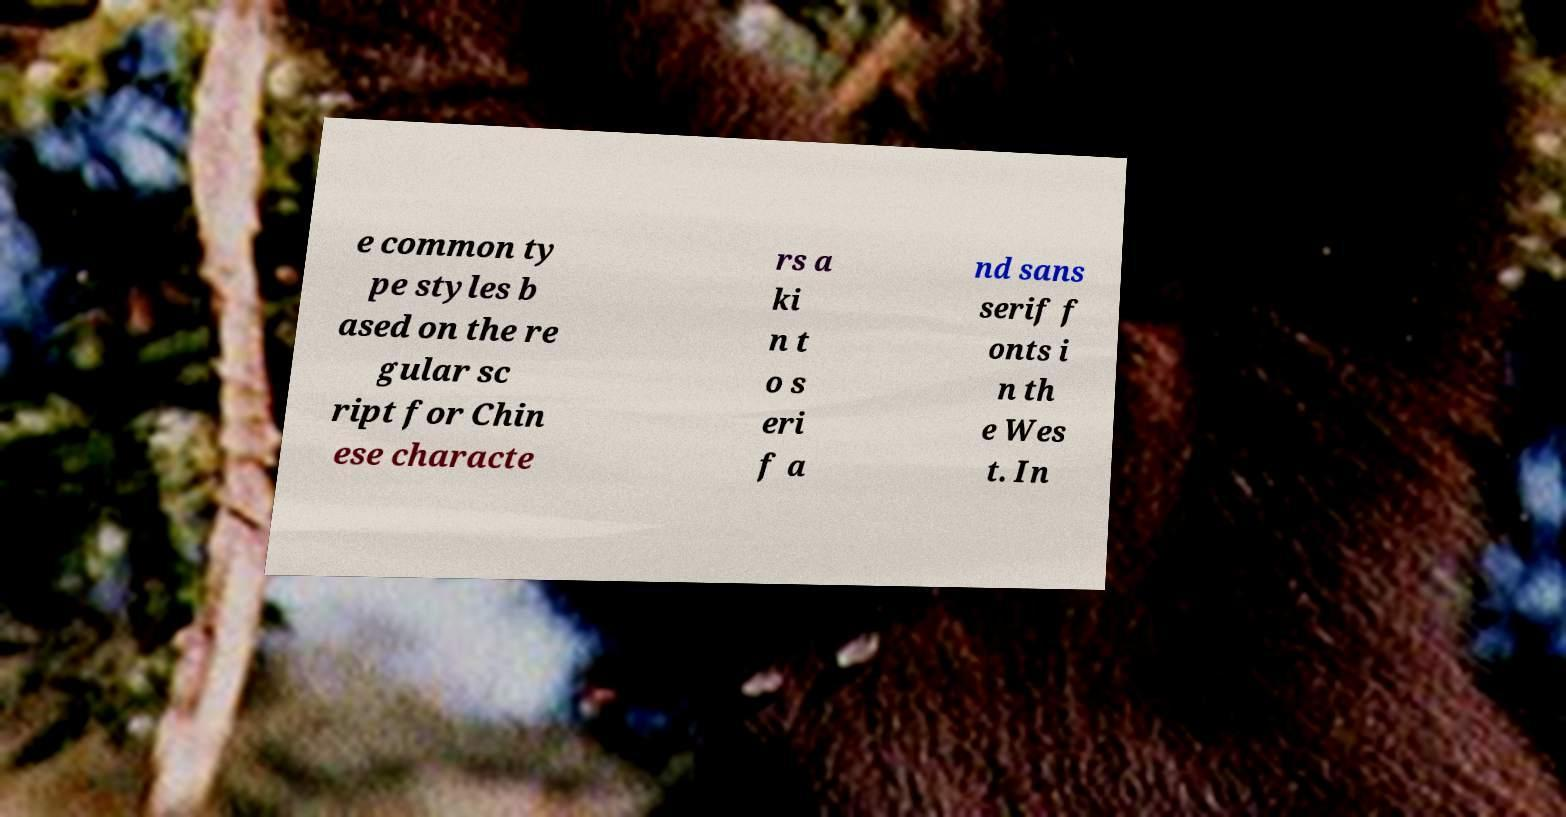Could you assist in decoding the text presented in this image and type it out clearly? e common ty pe styles b ased on the re gular sc ript for Chin ese characte rs a ki n t o s eri f a nd sans serif f onts i n th e Wes t. In 